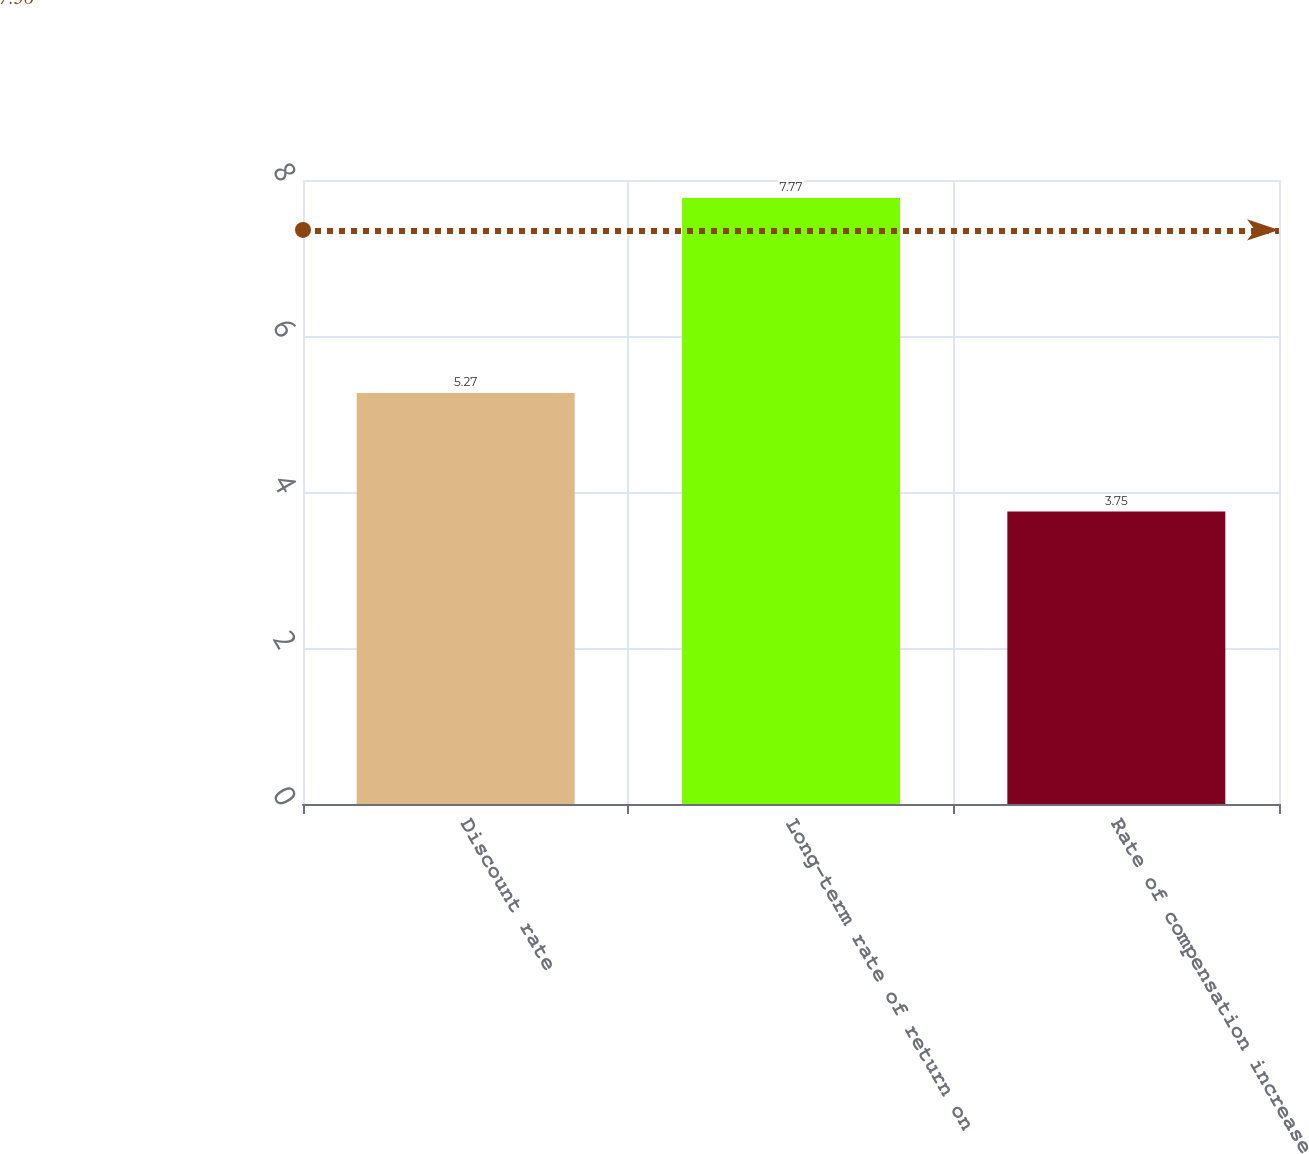<chart> <loc_0><loc_0><loc_500><loc_500><bar_chart><fcel>Discount rate<fcel>Long-term rate of return on<fcel>Rate of compensation increase<nl><fcel>5.27<fcel>7.77<fcel>3.75<nl></chart> 